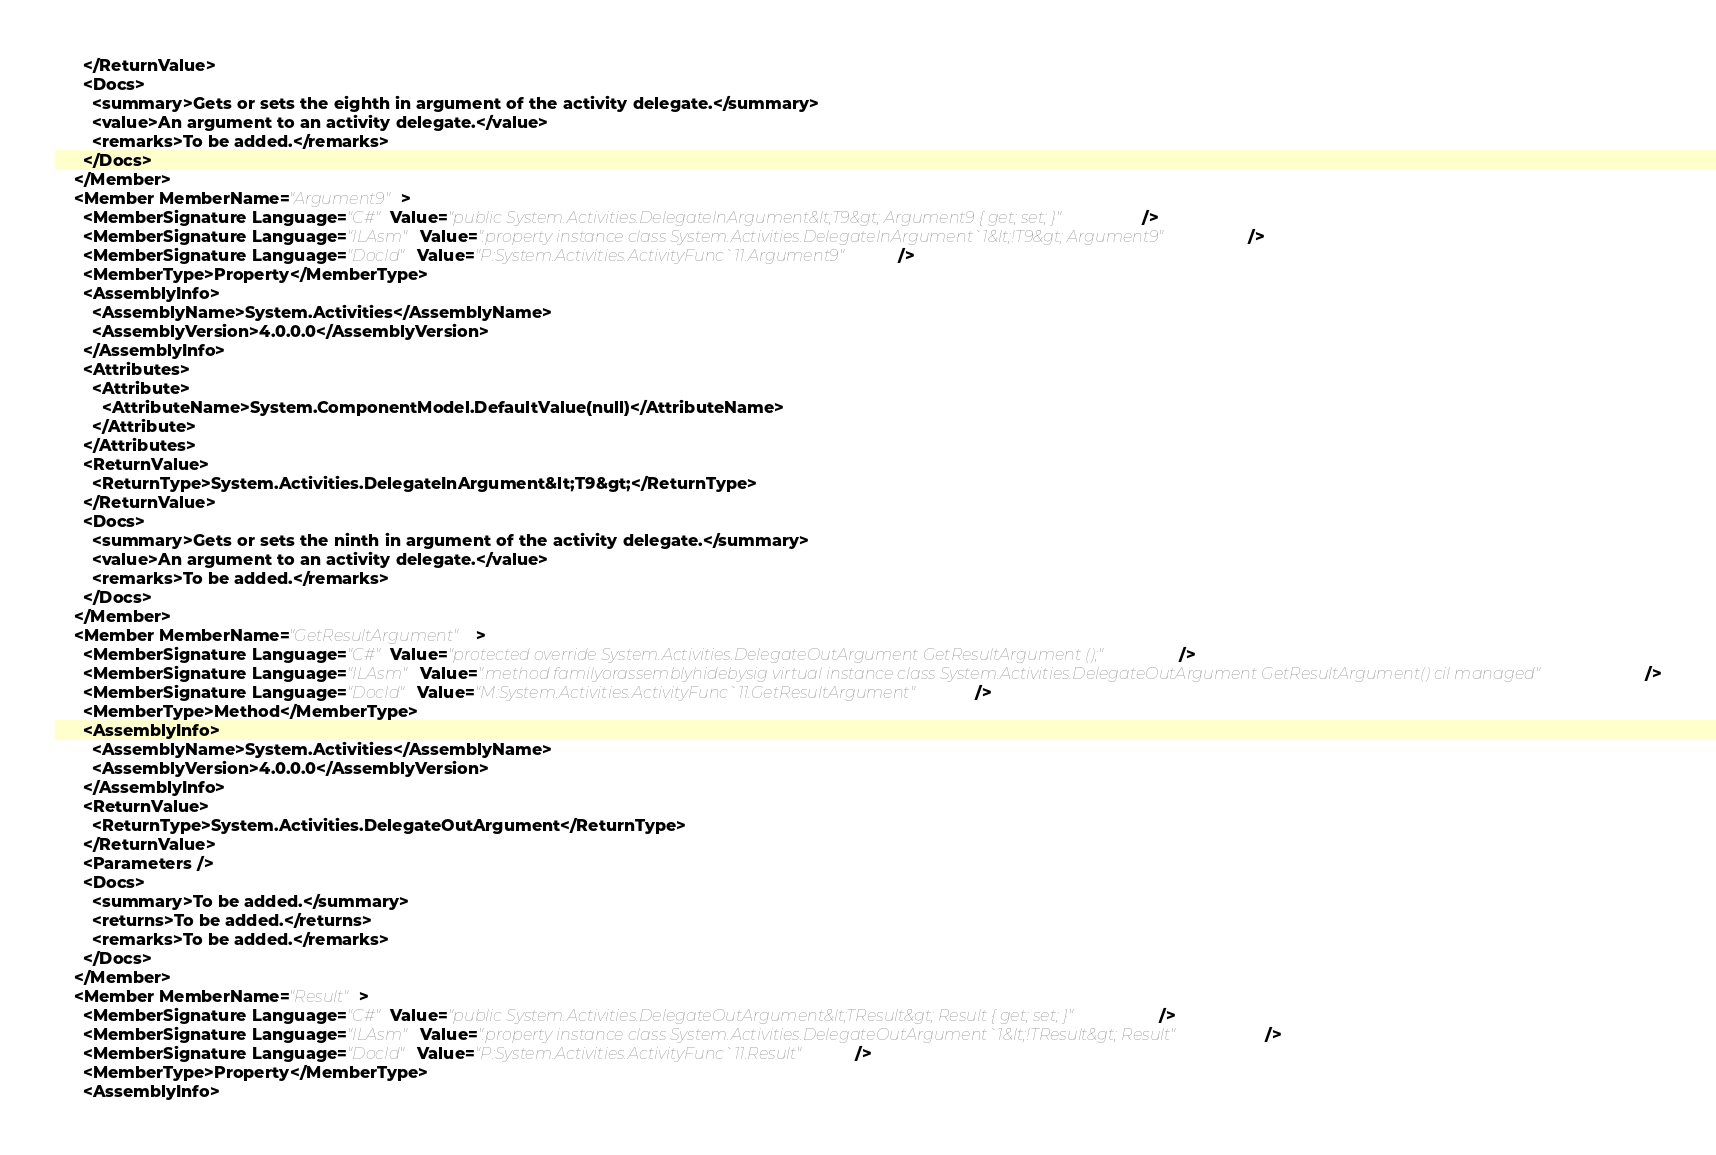<code> <loc_0><loc_0><loc_500><loc_500><_XML_>      </ReturnValue>
      <Docs>
        <summary>Gets or sets the eighth in argument of the activity delegate.</summary>
        <value>An argument to an activity delegate.</value>
        <remarks>To be added.</remarks>
      </Docs>
    </Member>
    <Member MemberName="Argument9">
      <MemberSignature Language="C#" Value="public System.Activities.DelegateInArgument&lt;T9&gt; Argument9 { get; set; }" />
      <MemberSignature Language="ILAsm" Value=".property instance class System.Activities.DelegateInArgument`1&lt;!T9&gt; Argument9" />
      <MemberSignature Language="DocId" Value="P:System.Activities.ActivityFunc`11.Argument9" />
      <MemberType>Property</MemberType>
      <AssemblyInfo>
        <AssemblyName>System.Activities</AssemblyName>
        <AssemblyVersion>4.0.0.0</AssemblyVersion>
      </AssemblyInfo>
      <Attributes>
        <Attribute>
          <AttributeName>System.ComponentModel.DefaultValue(null)</AttributeName>
        </Attribute>
      </Attributes>
      <ReturnValue>
        <ReturnType>System.Activities.DelegateInArgument&lt;T9&gt;</ReturnType>
      </ReturnValue>
      <Docs>
        <summary>Gets or sets the ninth in argument of the activity delegate.</summary>
        <value>An argument to an activity delegate.</value>
        <remarks>To be added.</remarks>
      </Docs>
    </Member>
    <Member MemberName="GetResultArgument">
      <MemberSignature Language="C#" Value="protected override System.Activities.DelegateOutArgument GetResultArgument ();" />
      <MemberSignature Language="ILAsm" Value=".method familyorassemblyhidebysig virtual instance class System.Activities.DelegateOutArgument GetResultArgument() cil managed" />
      <MemberSignature Language="DocId" Value="M:System.Activities.ActivityFunc`11.GetResultArgument" />
      <MemberType>Method</MemberType>
      <AssemblyInfo>
        <AssemblyName>System.Activities</AssemblyName>
        <AssemblyVersion>4.0.0.0</AssemblyVersion>
      </AssemblyInfo>
      <ReturnValue>
        <ReturnType>System.Activities.DelegateOutArgument</ReturnType>
      </ReturnValue>
      <Parameters />
      <Docs>
        <summary>To be added.</summary>
        <returns>To be added.</returns>
        <remarks>To be added.</remarks>
      </Docs>
    </Member>
    <Member MemberName="Result">
      <MemberSignature Language="C#" Value="public System.Activities.DelegateOutArgument&lt;TResult&gt; Result { get; set; }" />
      <MemberSignature Language="ILAsm" Value=".property instance class System.Activities.DelegateOutArgument`1&lt;!TResult&gt; Result" />
      <MemberSignature Language="DocId" Value="P:System.Activities.ActivityFunc`11.Result" />
      <MemberType>Property</MemberType>
      <AssemblyInfo></code> 